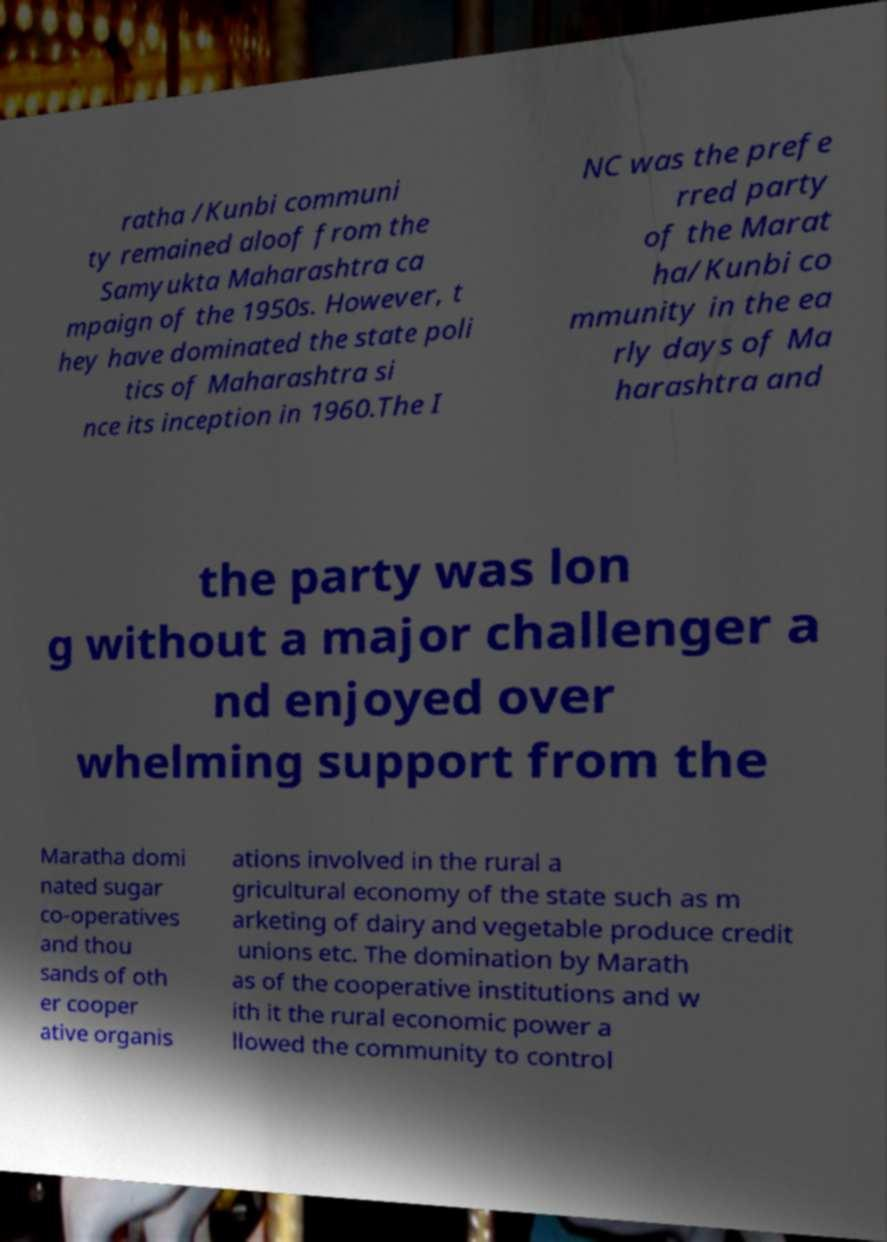I need the written content from this picture converted into text. Can you do that? ratha /Kunbi communi ty remained aloof from the Samyukta Maharashtra ca mpaign of the 1950s. However, t hey have dominated the state poli tics of Maharashtra si nce its inception in 1960.The I NC was the prefe rred party of the Marat ha/Kunbi co mmunity in the ea rly days of Ma harashtra and the party was lon g without a major challenger a nd enjoyed over whelming support from the Maratha domi nated sugar co-operatives and thou sands of oth er cooper ative organis ations involved in the rural a gricultural economy of the state such as m arketing of dairy and vegetable produce credit unions etc. The domination by Marath as of the cooperative institutions and w ith it the rural economic power a llowed the community to control 